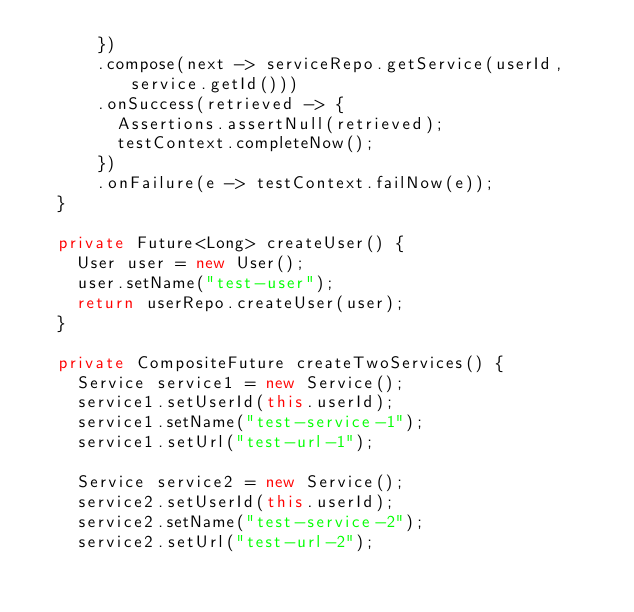Convert code to text. <code><loc_0><loc_0><loc_500><loc_500><_Java_>      })
      .compose(next -> serviceRepo.getService(userId, service.getId()))
      .onSuccess(retrieved -> {
        Assertions.assertNull(retrieved);
        testContext.completeNow();
      })
      .onFailure(e -> testContext.failNow(e));
  }

  private Future<Long> createUser() {
    User user = new User();
    user.setName("test-user");
    return userRepo.createUser(user);
  }

  private CompositeFuture createTwoServices() {
    Service service1 = new Service();
    service1.setUserId(this.userId);
    service1.setName("test-service-1");
    service1.setUrl("test-url-1");

    Service service2 = new Service();
    service2.setUserId(this.userId);
    service2.setName("test-service-2");
    service2.setUrl("test-url-2");</code> 